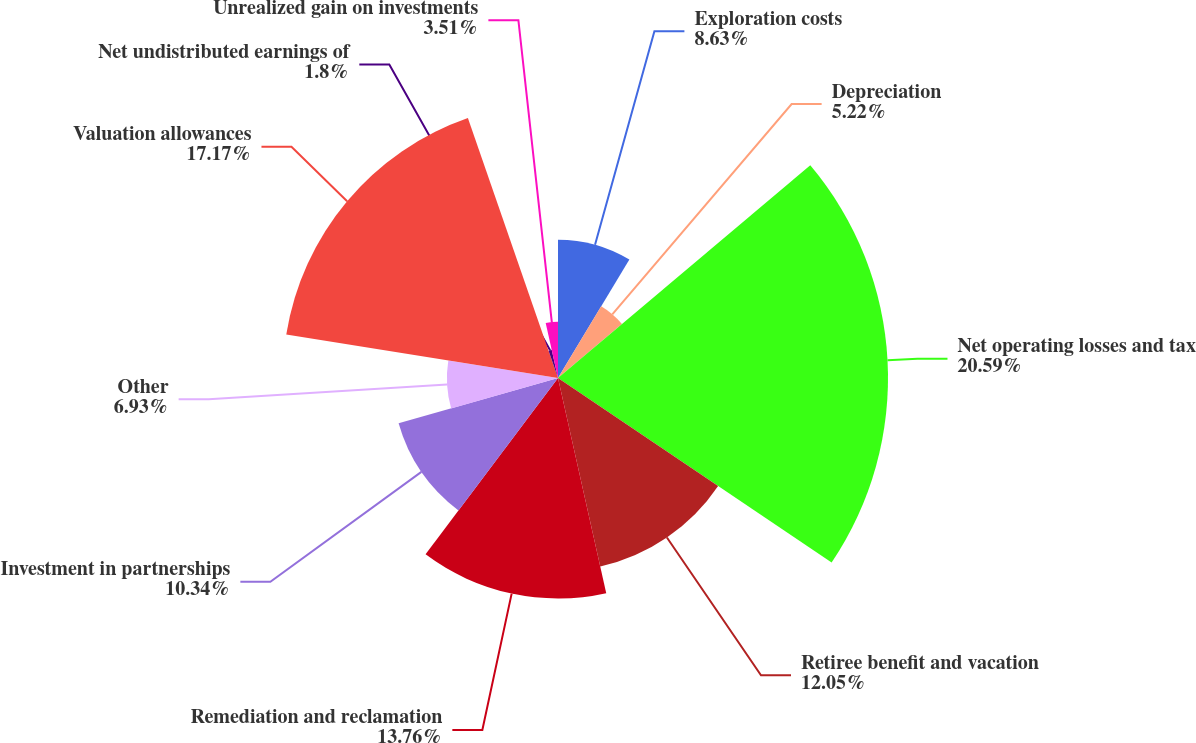Convert chart. <chart><loc_0><loc_0><loc_500><loc_500><pie_chart><fcel>Exploration costs<fcel>Depreciation<fcel>Net operating losses and tax<fcel>Retiree benefit and vacation<fcel>Remediation and reclamation<fcel>Investment in partnerships<fcel>Other<fcel>Valuation allowances<fcel>Net undistributed earnings of<fcel>Unrealized gain on investments<nl><fcel>8.63%<fcel>5.22%<fcel>20.59%<fcel>12.05%<fcel>13.76%<fcel>10.34%<fcel>6.93%<fcel>17.17%<fcel>1.8%<fcel>3.51%<nl></chart> 